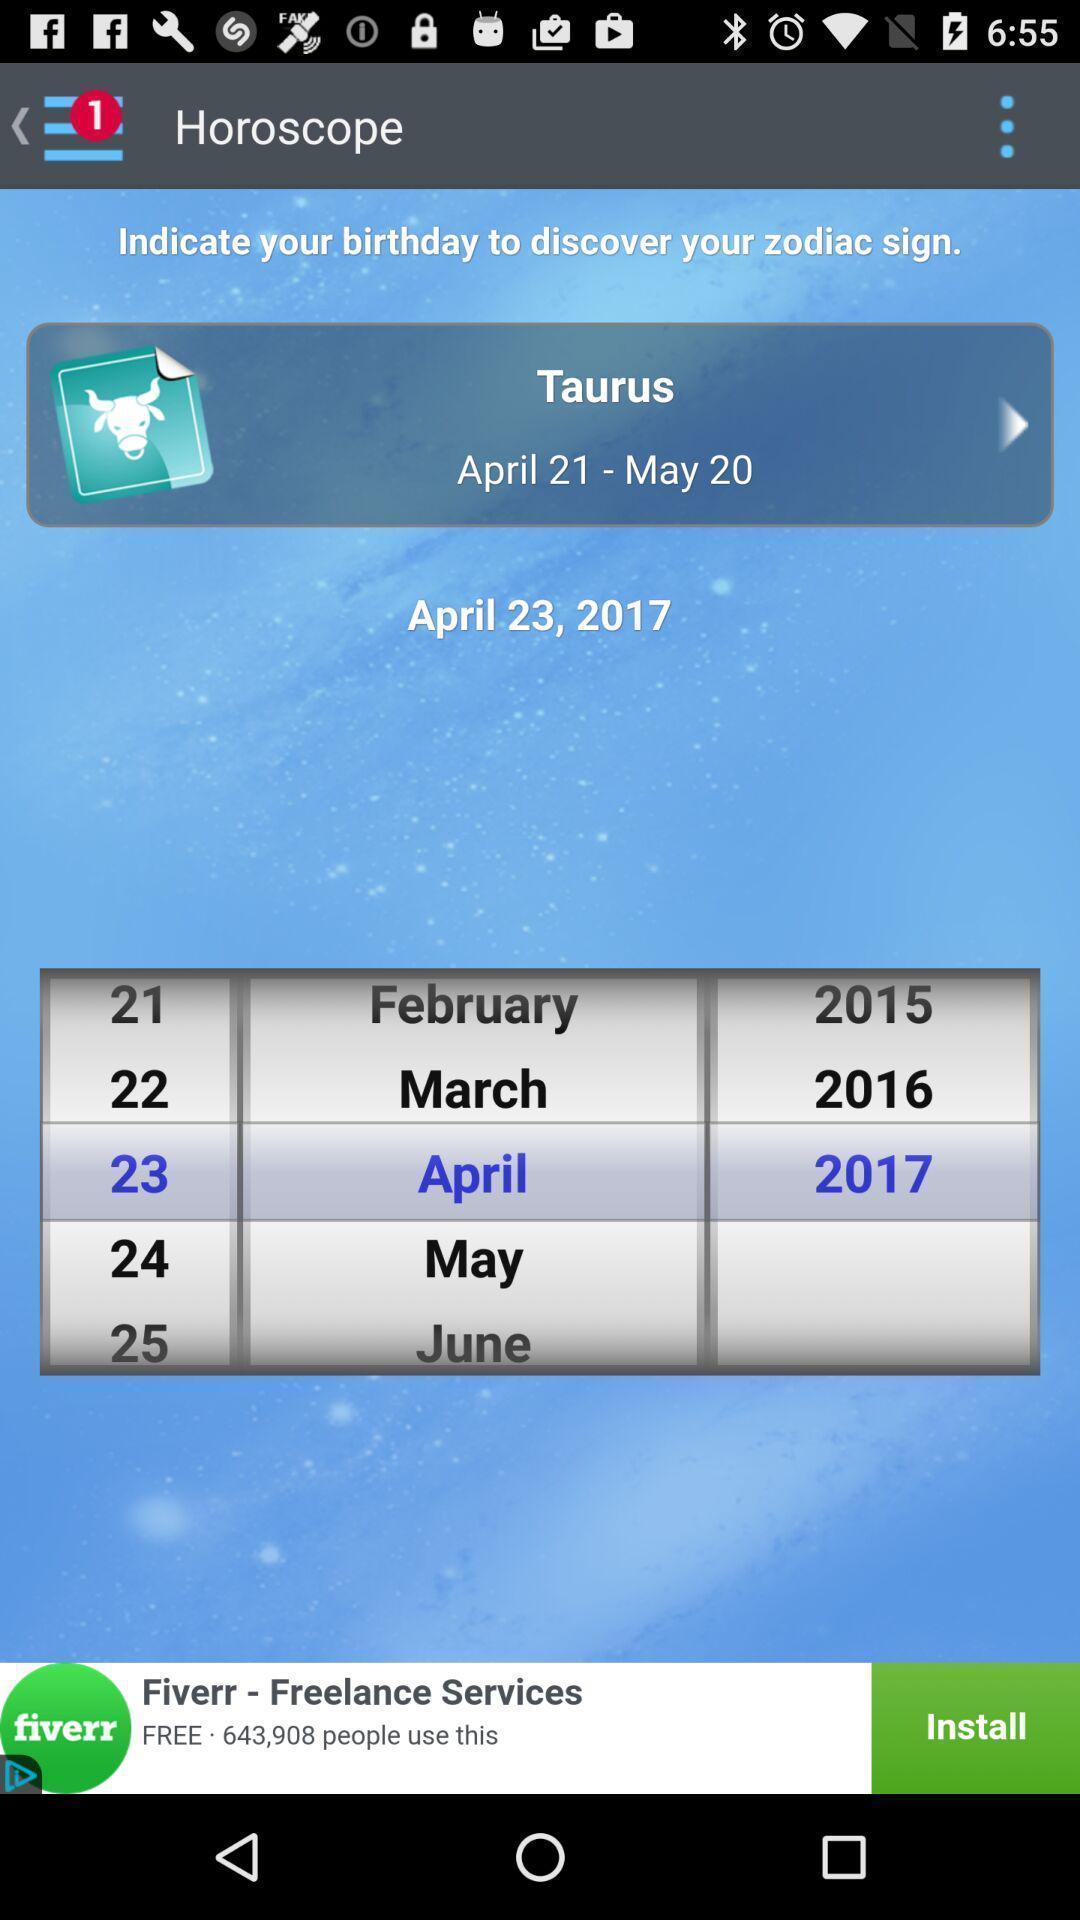Explain the elements present in this screenshot. Page shows the taurus date and year on zodiac app. 